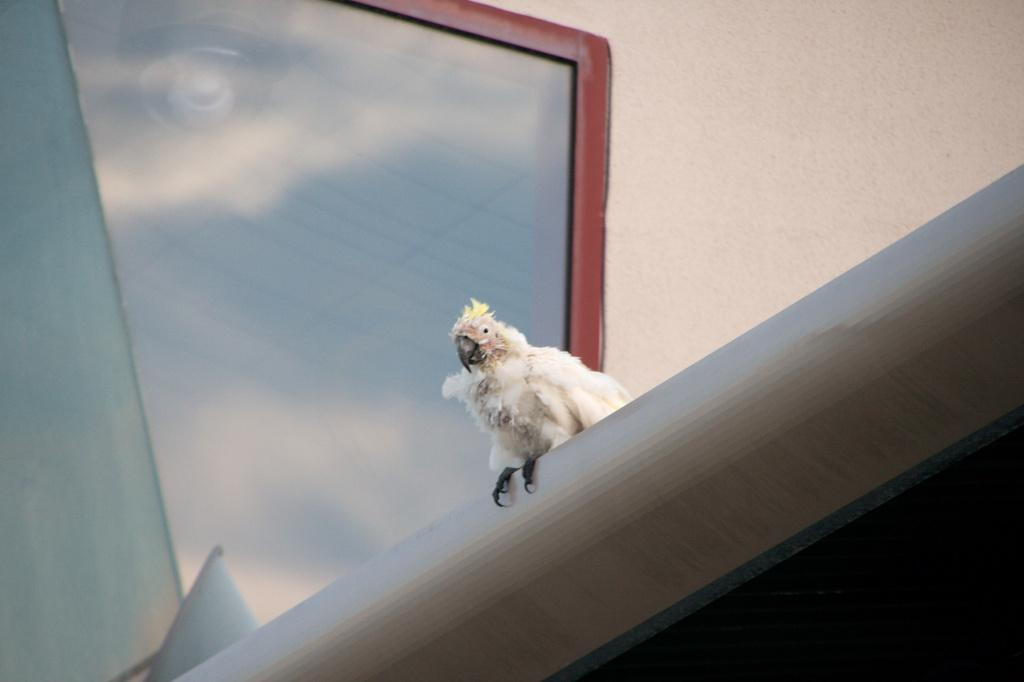What type of animal is in the image? There is a bird in the image. What is the bird standing on? The bird is on a gray surface. What can be seen in the background of the image? There is a wall and a glass object in the background of the image. What type of quiver is the bird holding in the image? There is no quiver present in the image; it only features a bird on a gray surface with a wall and a glass object in the background. 